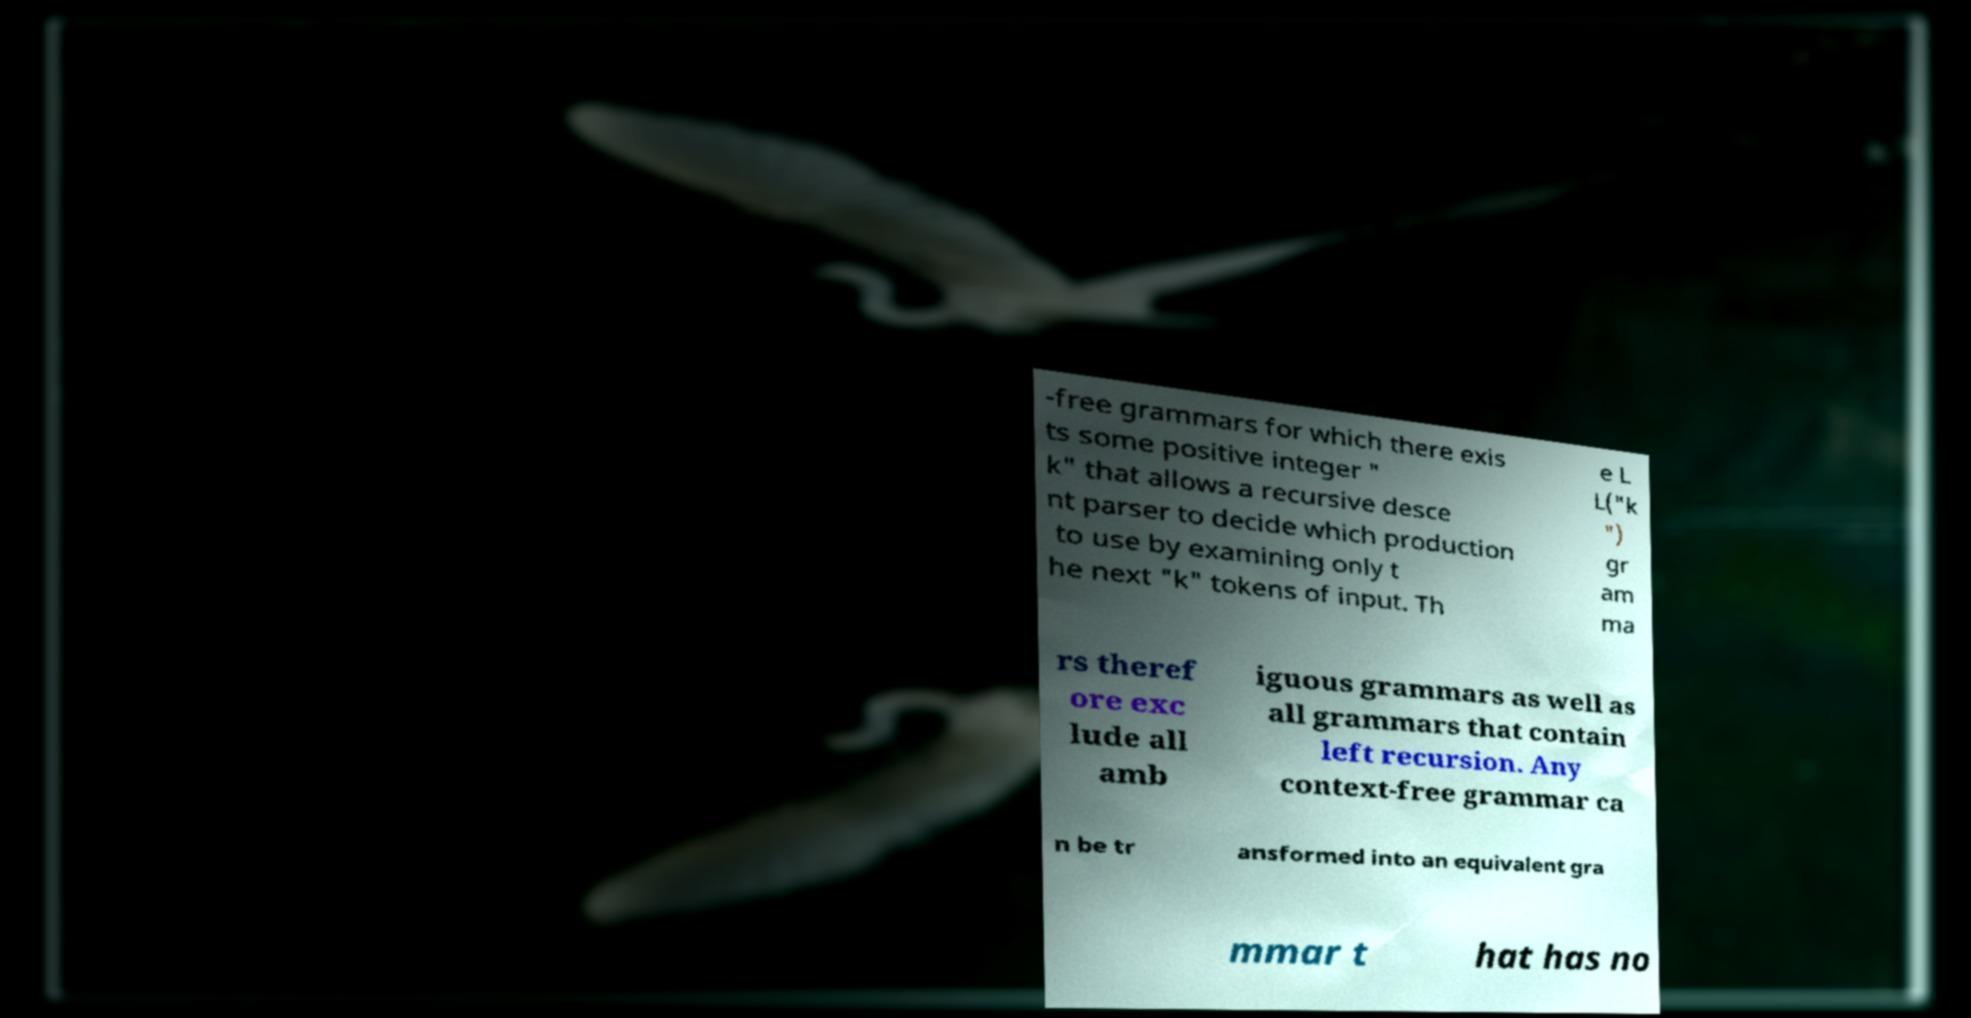Please identify and transcribe the text found in this image. -free grammars for which there exis ts some positive integer " k" that allows a recursive desce nt parser to decide which production to use by examining only t he next "k" tokens of input. Th e L L("k ") gr am ma rs theref ore exc lude all amb iguous grammars as well as all grammars that contain left recursion. Any context-free grammar ca n be tr ansformed into an equivalent gra mmar t hat has no 